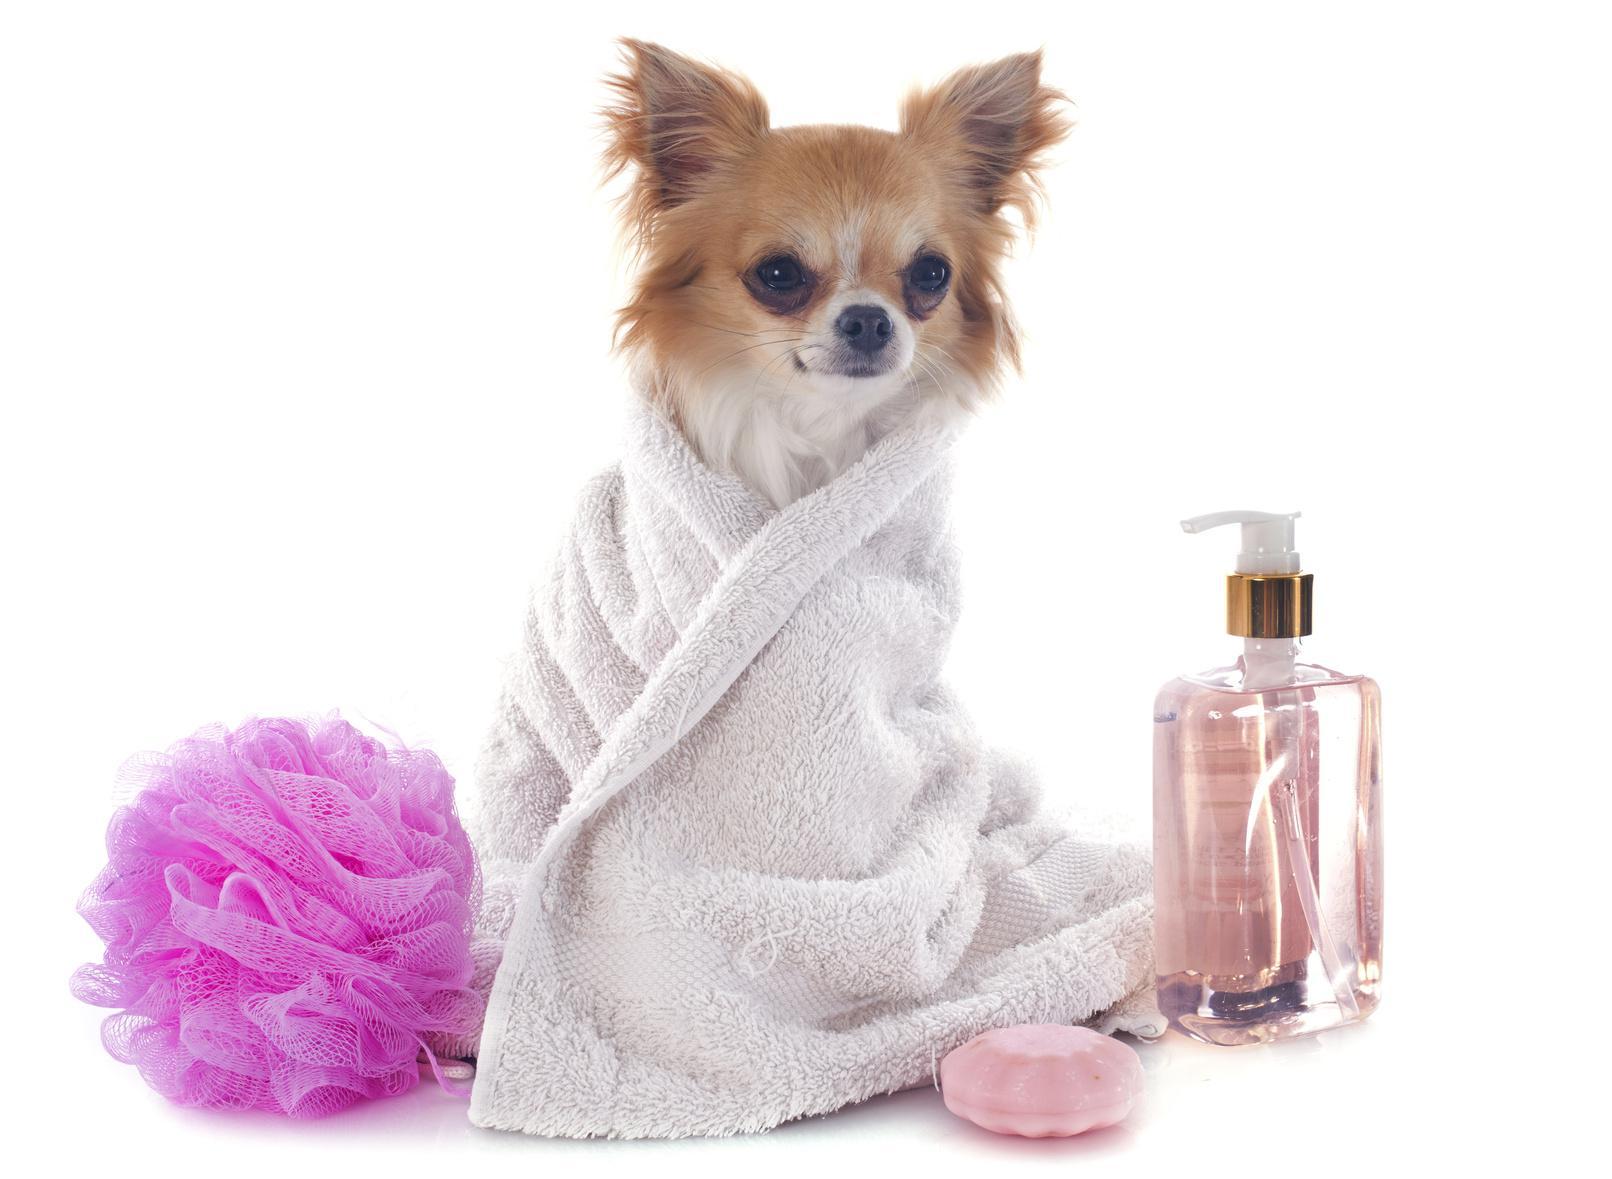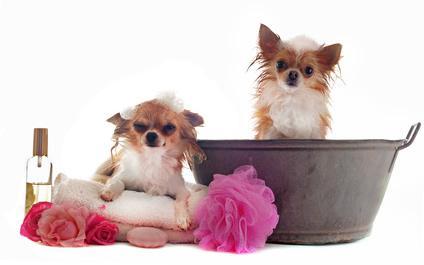The first image is the image on the left, the second image is the image on the right. Given the left and right images, does the statement "An image includes two dogs, both in some type of container that features a polka-dotted pinkish element." hold true? Answer yes or no. No. The first image is the image on the left, the second image is the image on the right. Analyze the images presented: Is the assertion "One image shows exactly two dogs with each dog in its own separate container or placemat; no two dogs share a spot." valid? Answer yes or no. Yes. 